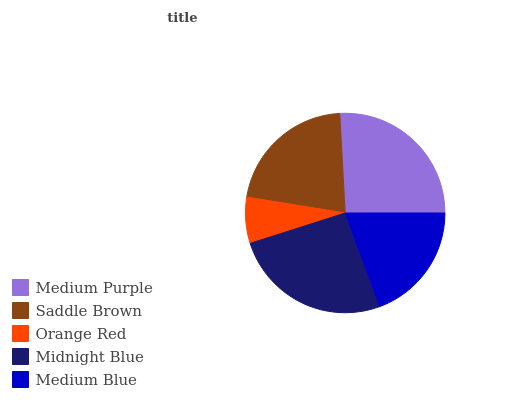Is Orange Red the minimum?
Answer yes or no. Yes. Is Medium Purple the maximum?
Answer yes or no. Yes. Is Saddle Brown the minimum?
Answer yes or no. No. Is Saddle Brown the maximum?
Answer yes or no. No. Is Medium Purple greater than Saddle Brown?
Answer yes or no. Yes. Is Saddle Brown less than Medium Purple?
Answer yes or no. Yes. Is Saddle Brown greater than Medium Purple?
Answer yes or no. No. Is Medium Purple less than Saddle Brown?
Answer yes or no. No. Is Saddle Brown the high median?
Answer yes or no. Yes. Is Saddle Brown the low median?
Answer yes or no. Yes. Is Orange Red the high median?
Answer yes or no. No. Is Orange Red the low median?
Answer yes or no. No. 